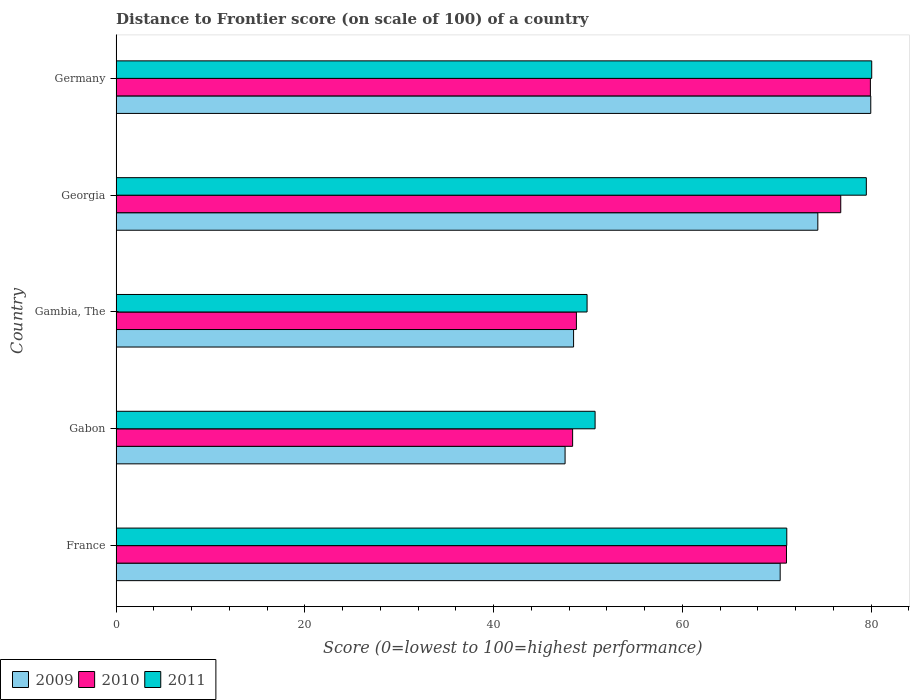How many different coloured bars are there?
Make the answer very short. 3. What is the label of the 1st group of bars from the top?
Give a very brief answer. Germany. In how many cases, is the number of bars for a given country not equal to the number of legend labels?
Provide a succinct answer. 0. What is the distance to frontier score of in 2010 in Gambia, The?
Ensure brevity in your answer.  48.77. Across all countries, what is the maximum distance to frontier score of in 2010?
Provide a succinct answer. 79.92. Across all countries, what is the minimum distance to frontier score of in 2011?
Offer a terse response. 49.9. In which country was the distance to frontier score of in 2010 maximum?
Make the answer very short. Germany. In which country was the distance to frontier score of in 2011 minimum?
Provide a succinct answer. Gambia, The. What is the total distance to frontier score of in 2010 in the graph?
Make the answer very short. 324.87. What is the difference between the distance to frontier score of in 2011 in France and that in Georgia?
Keep it short and to the point. -8.43. What is the difference between the distance to frontier score of in 2009 in Gambia, The and the distance to frontier score of in 2011 in France?
Make the answer very short. -22.59. What is the average distance to frontier score of in 2009 per country?
Provide a short and direct response. 64.14. What is the difference between the distance to frontier score of in 2011 and distance to frontier score of in 2009 in Gabon?
Your answer should be very brief. 3.18. In how many countries, is the distance to frontier score of in 2010 greater than 20 ?
Provide a short and direct response. 5. What is the ratio of the distance to frontier score of in 2011 in France to that in Georgia?
Offer a very short reply. 0.89. Is the distance to frontier score of in 2011 in France less than that in Gabon?
Offer a terse response. No. Is the difference between the distance to frontier score of in 2011 in France and Gambia, The greater than the difference between the distance to frontier score of in 2009 in France and Gambia, The?
Provide a succinct answer. No. What is the difference between the highest and the second highest distance to frontier score of in 2010?
Your answer should be compact. 3.14. What is the difference between the highest and the lowest distance to frontier score of in 2009?
Your answer should be very brief. 32.39. What does the 2nd bar from the top in Gambia, The represents?
Offer a very short reply. 2010. How many bars are there?
Your answer should be very brief. 15. Are all the bars in the graph horizontal?
Make the answer very short. Yes. How many countries are there in the graph?
Your response must be concise. 5. What is the difference between two consecutive major ticks on the X-axis?
Make the answer very short. 20. Are the values on the major ticks of X-axis written in scientific E-notation?
Keep it short and to the point. No. Does the graph contain grids?
Your response must be concise. No. Where does the legend appear in the graph?
Your answer should be very brief. Bottom left. How many legend labels are there?
Give a very brief answer. 3. How are the legend labels stacked?
Your response must be concise. Horizontal. What is the title of the graph?
Your answer should be very brief. Distance to Frontier score (on scale of 100) of a country. Does "2006" appear as one of the legend labels in the graph?
Make the answer very short. No. What is the label or title of the X-axis?
Your response must be concise. Score (0=lowest to 100=highest performance). What is the Score (0=lowest to 100=highest performance) in 2009 in France?
Provide a succinct answer. 70.36. What is the Score (0=lowest to 100=highest performance) of 2010 in France?
Offer a very short reply. 71.03. What is the Score (0=lowest to 100=highest performance) in 2011 in France?
Keep it short and to the point. 71.06. What is the Score (0=lowest to 100=highest performance) in 2009 in Gabon?
Ensure brevity in your answer.  47.57. What is the Score (0=lowest to 100=highest performance) of 2010 in Gabon?
Make the answer very short. 48.37. What is the Score (0=lowest to 100=highest performance) of 2011 in Gabon?
Offer a very short reply. 50.75. What is the Score (0=lowest to 100=highest performance) of 2009 in Gambia, The?
Make the answer very short. 48.47. What is the Score (0=lowest to 100=highest performance) in 2010 in Gambia, The?
Your answer should be compact. 48.77. What is the Score (0=lowest to 100=highest performance) of 2011 in Gambia, The?
Ensure brevity in your answer.  49.9. What is the Score (0=lowest to 100=highest performance) of 2009 in Georgia?
Your answer should be very brief. 74.35. What is the Score (0=lowest to 100=highest performance) of 2010 in Georgia?
Your answer should be very brief. 76.78. What is the Score (0=lowest to 100=highest performance) in 2011 in Georgia?
Your answer should be compact. 79.49. What is the Score (0=lowest to 100=highest performance) of 2009 in Germany?
Give a very brief answer. 79.96. What is the Score (0=lowest to 100=highest performance) in 2010 in Germany?
Provide a short and direct response. 79.92. What is the Score (0=lowest to 100=highest performance) of 2011 in Germany?
Your answer should be very brief. 80.06. Across all countries, what is the maximum Score (0=lowest to 100=highest performance) in 2009?
Your answer should be compact. 79.96. Across all countries, what is the maximum Score (0=lowest to 100=highest performance) of 2010?
Ensure brevity in your answer.  79.92. Across all countries, what is the maximum Score (0=lowest to 100=highest performance) of 2011?
Provide a short and direct response. 80.06. Across all countries, what is the minimum Score (0=lowest to 100=highest performance) of 2009?
Make the answer very short. 47.57. Across all countries, what is the minimum Score (0=lowest to 100=highest performance) of 2010?
Ensure brevity in your answer.  48.37. Across all countries, what is the minimum Score (0=lowest to 100=highest performance) of 2011?
Provide a succinct answer. 49.9. What is the total Score (0=lowest to 100=highest performance) of 2009 in the graph?
Your answer should be very brief. 320.71. What is the total Score (0=lowest to 100=highest performance) of 2010 in the graph?
Provide a succinct answer. 324.87. What is the total Score (0=lowest to 100=highest performance) in 2011 in the graph?
Make the answer very short. 331.26. What is the difference between the Score (0=lowest to 100=highest performance) of 2009 in France and that in Gabon?
Offer a very short reply. 22.79. What is the difference between the Score (0=lowest to 100=highest performance) of 2010 in France and that in Gabon?
Your answer should be very brief. 22.66. What is the difference between the Score (0=lowest to 100=highest performance) of 2011 in France and that in Gabon?
Offer a terse response. 20.31. What is the difference between the Score (0=lowest to 100=highest performance) of 2009 in France and that in Gambia, The?
Provide a short and direct response. 21.89. What is the difference between the Score (0=lowest to 100=highest performance) in 2010 in France and that in Gambia, The?
Ensure brevity in your answer.  22.26. What is the difference between the Score (0=lowest to 100=highest performance) of 2011 in France and that in Gambia, The?
Provide a short and direct response. 21.16. What is the difference between the Score (0=lowest to 100=highest performance) in 2009 in France and that in Georgia?
Provide a succinct answer. -3.99. What is the difference between the Score (0=lowest to 100=highest performance) in 2010 in France and that in Georgia?
Ensure brevity in your answer.  -5.75. What is the difference between the Score (0=lowest to 100=highest performance) of 2011 in France and that in Georgia?
Offer a very short reply. -8.43. What is the difference between the Score (0=lowest to 100=highest performance) of 2010 in France and that in Germany?
Give a very brief answer. -8.89. What is the difference between the Score (0=lowest to 100=highest performance) of 2011 in France and that in Germany?
Your answer should be compact. -9. What is the difference between the Score (0=lowest to 100=highest performance) of 2009 in Gabon and that in Georgia?
Provide a short and direct response. -26.78. What is the difference between the Score (0=lowest to 100=highest performance) of 2010 in Gabon and that in Georgia?
Your response must be concise. -28.41. What is the difference between the Score (0=lowest to 100=highest performance) of 2011 in Gabon and that in Georgia?
Ensure brevity in your answer.  -28.74. What is the difference between the Score (0=lowest to 100=highest performance) in 2009 in Gabon and that in Germany?
Provide a succinct answer. -32.39. What is the difference between the Score (0=lowest to 100=highest performance) in 2010 in Gabon and that in Germany?
Provide a short and direct response. -31.55. What is the difference between the Score (0=lowest to 100=highest performance) of 2011 in Gabon and that in Germany?
Ensure brevity in your answer.  -29.31. What is the difference between the Score (0=lowest to 100=highest performance) of 2009 in Gambia, The and that in Georgia?
Your response must be concise. -25.88. What is the difference between the Score (0=lowest to 100=highest performance) in 2010 in Gambia, The and that in Georgia?
Provide a succinct answer. -28.01. What is the difference between the Score (0=lowest to 100=highest performance) in 2011 in Gambia, The and that in Georgia?
Ensure brevity in your answer.  -29.59. What is the difference between the Score (0=lowest to 100=highest performance) in 2009 in Gambia, The and that in Germany?
Make the answer very short. -31.49. What is the difference between the Score (0=lowest to 100=highest performance) in 2010 in Gambia, The and that in Germany?
Your response must be concise. -31.15. What is the difference between the Score (0=lowest to 100=highest performance) of 2011 in Gambia, The and that in Germany?
Your answer should be compact. -30.16. What is the difference between the Score (0=lowest to 100=highest performance) of 2009 in Georgia and that in Germany?
Your answer should be very brief. -5.61. What is the difference between the Score (0=lowest to 100=highest performance) in 2010 in Georgia and that in Germany?
Give a very brief answer. -3.14. What is the difference between the Score (0=lowest to 100=highest performance) of 2011 in Georgia and that in Germany?
Provide a short and direct response. -0.57. What is the difference between the Score (0=lowest to 100=highest performance) in 2009 in France and the Score (0=lowest to 100=highest performance) in 2010 in Gabon?
Give a very brief answer. 21.99. What is the difference between the Score (0=lowest to 100=highest performance) in 2009 in France and the Score (0=lowest to 100=highest performance) in 2011 in Gabon?
Keep it short and to the point. 19.61. What is the difference between the Score (0=lowest to 100=highest performance) of 2010 in France and the Score (0=lowest to 100=highest performance) of 2011 in Gabon?
Ensure brevity in your answer.  20.28. What is the difference between the Score (0=lowest to 100=highest performance) in 2009 in France and the Score (0=lowest to 100=highest performance) in 2010 in Gambia, The?
Offer a very short reply. 21.59. What is the difference between the Score (0=lowest to 100=highest performance) in 2009 in France and the Score (0=lowest to 100=highest performance) in 2011 in Gambia, The?
Give a very brief answer. 20.46. What is the difference between the Score (0=lowest to 100=highest performance) of 2010 in France and the Score (0=lowest to 100=highest performance) of 2011 in Gambia, The?
Your response must be concise. 21.13. What is the difference between the Score (0=lowest to 100=highest performance) of 2009 in France and the Score (0=lowest to 100=highest performance) of 2010 in Georgia?
Provide a succinct answer. -6.42. What is the difference between the Score (0=lowest to 100=highest performance) in 2009 in France and the Score (0=lowest to 100=highest performance) in 2011 in Georgia?
Provide a succinct answer. -9.13. What is the difference between the Score (0=lowest to 100=highest performance) of 2010 in France and the Score (0=lowest to 100=highest performance) of 2011 in Georgia?
Ensure brevity in your answer.  -8.46. What is the difference between the Score (0=lowest to 100=highest performance) of 2009 in France and the Score (0=lowest to 100=highest performance) of 2010 in Germany?
Offer a terse response. -9.56. What is the difference between the Score (0=lowest to 100=highest performance) in 2010 in France and the Score (0=lowest to 100=highest performance) in 2011 in Germany?
Offer a very short reply. -9.03. What is the difference between the Score (0=lowest to 100=highest performance) of 2009 in Gabon and the Score (0=lowest to 100=highest performance) of 2011 in Gambia, The?
Your answer should be compact. -2.33. What is the difference between the Score (0=lowest to 100=highest performance) of 2010 in Gabon and the Score (0=lowest to 100=highest performance) of 2011 in Gambia, The?
Keep it short and to the point. -1.53. What is the difference between the Score (0=lowest to 100=highest performance) of 2009 in Gabon and the Score (0=lowest to 100=highest performance) of 2010 in Georgia?
Your answer should be very brief. -29.21. What is the difference between the Score (0=lowest to 100=highest performance) in 2009 in Gabon and the Score (0=lowest to 100=highest performance) in 2011 in Georgia?
Provide a short and direct response. -31.92. What is the difference between the Score (0=lowest to 100=highest performance) in 2010 in Gabon and the Score (0=lowest to 100=highest performance) in 2011 in Georgia?
Your answer should be compact. -31.12. What is the difference between the Score (0=lowest to 100=highest performance) of 2009 in Gabon and the Score (0=lowest to 100=highest performance) of 2010 in Germany?
Ensure brevity in your answer.  -32.35. What is the difference between the Score (0=lowest to 100=highest performance) in 2009 in Gabon and the Score (0=lowest to 100=highest performance) in 2011 in Germany?
Offer a terse response. -32.49. What is the difference between the Score (0=lowest to 100=highest performance) of 2010 in Gabon and the Score (0=lowest to 100=highest performance) of 2011 in Germany?
Your answer should be compact. -31.69. What is the difference between the Score (0=lowest to 100=highest performance) in 2009 in Gambia, The and the Score (0=lowest to 100=highest performance) in 2010 in Georgia?
Your response must be concise. -28.31. What is the difference between the Score (0=lowest to 100=highest performance) in 2009 in Gambia, The and the Score (0=lowest to 100=highest performance) in 2011 in Georgia?
Offer a very short reply. -31.02. What is the difference between the Score (0=lowest to 100=highest performance) in 2010 in Gambia, The and the Score (0=lowest to 100=highest performance) in 2011 in Georgia?
Make the answer very short. -30.72. What is the difference between the Score (0=lowest to 100=highest performance) in 2009 in Gambia, The and the Score (0=lowest to 100=highest performance) in 2010 in Germany?
Offer a terse response. -31.45. What is the difference between the Score (0=lowest to 100=highest performance) of 2009 in Gambia, The and the Score (0=lowest to 100=highest performance) of 2011 in Germany?
Ensure brevity in your answer.  -31.59. What is the difference between the Score (0=lowest to 100=highest performance) in 2010 in Gambia, The and the Score (0=lowest to 100=highest performance) in 2011 in Germany?
Offer a terse response. -31.29. What is the difference between the Score (0=lowest to 100=highest performance) in 2009 in Georgia and the Score (0=lowest to 100=highest performance) in 2010 in Germany?
Your answer should be compact. -5.57. What is the difference between the Score (0=lowest to 100=highest performance) in 2009 in Georgia and the Score (0=lowest to 100=highest performance) in 2011 in Germany?
Ensure brevity in your answer.  -5.71. What is the difference between the Score (0=lowest to 100=highest performance) in 2010 in Georgia and the Score (0=lowest to 100=highest performance) in 2011 in Germany?
Your response must be concise. -3.28. What is the average Score (0=lowest to 100=highest performance) in 2009 per country?
Provide a short and direct response. 64.14. What is the average Score (0=lowest to 100=highest performance) of 2010 per country?
Keep it short and to the point. 64.97. What is the average Score (0=lowest to 100=highest performance) in 2011 per country?
Your answer should be very brief. 66.25. What is the difference between the Score (0=lowest to 100=highest performance) of 2009 and Score (0=lowest to 100=highest performance) of 2010 in France?
Provide a short and direct response. -0.67. What is the difference between the Score (0=lowest to 100=highest performance) of 2009 and Score (0=lowest to 100=highest performance) of 2011 in France?
Make the answer very short. -0.7. What is the difference between the Score (0=lowest to 100=highest performance) of 2010 and Score (0=lowest to 100=highest performance) of 2011 in France?
Provide a short and direct response. -0.03. What is the difference between the Score (0=lowest to 100=highest performance) of 2009 and Score (0=lowest to 100=highest performance) of 2011 in Gabon?
Provide a succinct answer. -3.18. What is the difference between the Score (0=lowest to 100=highest performance) in 2010 and Score (0=lowest to 100=highest performance) in 2011 in Gabon?
Offer a terse response. -2.38. What is the difference between the Score (0=lowest to 100=highest performance) in 2009 and Score (0=lowest to 100=highest performance) in 2011 in Gambia, The?
Make the answer very short. -1.43. What is the difference between the Score (0=lowest to 100=highest performance) of 2010 and Score (0=lowest to 100=highest performance) of 2011 in Gambia, The?
Give a very brief answer. -1.13. What is the difference between the Score (0=lowest to 100=highest performance) of 2009 and Score (0=lowest to 100=highest performance) of 2010 in Georgia?
Give a very brief answer. -2.43. What is the difference between the Score (0=lowest to 100=highest performance) in 2009 and Score (0=lowest to 100=highest performance) in 2011 in Georgia?
Offer a very short reply. -5.14. What is the difference between the Score (0=lowest to 100=highest performance) in 2010 and Score (0=lowest to 100=highest performance) in 2011 in Georgia?
Offer a terse response. -2.71. What is the difference between the Score (0=lowest to 100=highest performance) of 2009 and Score (0=lowest to 100=highest performance) of 2010 in Germany?
Offer a very short reply. 0.04. What is the difference between the Score (0=lowest to 100=highest performance) in 2009 and Score (0=lowest to 100=highest performance) in 2011 in Germany?
Provide a succinct answer. -0.1. What is the difference between the Score (0=lowest to 100=highest performance) in 2010 and Score (0=lowest to 100=highest performance) in 2011 in Germany?
Your response must be concise. -0.14. What is the ratio of the Score (0=lowest to 100=highest performance) in 2009 in France to that in Gabon?
Offer a terse response. 1.48. What is the ratio of the Score (0=lowest to 100=highest performance) of 2010 in France to that in Gabon?
Keep it short and to the point. 1.47. What is the ratio of the Score (0=lowest to 100=highest performance) in 2011 in France to that in Gabon?
Offer a terse response. 1.4. What is the ratio of the Score (0=lowest to 100=highest performance) of 2009 in France to that in Gambia, The?
Offer a very short reply. 1.45. What is the ratio of the Score (0=lowest to 100=highest performance) of 2010 in France to that in Gambia, The?
Give a very brief answer. 1.46. What is the ratio of the Score (0=lowest to 100=highest performance) of 2011 in France to that in Gambia, The?
Your answer should be compact. 1.42. What is the ratio of the Score (0=lowest to 100=highest performance) of 2009 in France to that in Georgia?
Ensure brevity in your answer.  0.95. What is the ratio of the Score (0=lowest to 100=highest performance) of 2010 in France to that in Georgia?
Provide a succinct answer. 0.93. What is the ratio of the Score (0=lowest to 100=highest performance) in 2011 in France to that in Georgia?
Keep it short and to the point. 0.89. What is the ratio of the Score (0=lowest to 100=highest performance) of 2009 in France to that in Germany?
Ensure brevity in your answer.  0.88. What is the ratio of the Score (0=lowest to 100=highest performance) in 2010 in France to that in Germany?
Keep it short and to the point. 0.89. What is the ratio of the Score (0=lowest to 100=highest performance) in 2011 in France to that in Germany?
Provide a short and direct response. 0.89. What is the ratio of the Score (0=lowest to 100=highest performance) of 2009 in Gabon to that in Gambia, The?
Make the answer very short. 0.98. What is the ratio of the Score (0=lowest to 100=highest performance) of 2009 in Gabon to that in Georgia?
Your answer should be compact. 0.64. What is the ratio of the Score (0=lowest to 100=highest performance) in 2010 in Gabon to that in Georgia?
Your response must be concise. 0.63. What is the ratio of the Score (0=lowest to 100=highest performance) in 2011 in Gabon to that in Georgia?
Provide a succinct answer. 0.64. What is the ratio of the Score (0=lowest to 100=highest performance) in 2009 in Gabon to that in Germany?
Keep it short and to the point. 0.59. What is the ratio of the Score (0=lowest to 100=highest performance) of 2010 in Gabon to that in Germany?
Keep it short and to the point. 0.61. What is the ratio of the Score (0=lowest to 100=highest performance) of 2011 in Gabon to that in Germany?
Your answer should be compact. 0.63. What is the ratio of the Score (0=lowest to 100=highest performance) of 2009 in Gambia, The to that in Georgia?
Keep it short and to the point. 0.65. What is the ratio of the Score (0=lowest to 100=highest performance) in 2010 in Gambia, The to that in Georgia?
Ensure brevity in your answer.  0.64. What is the ratio of the Score (0=lowest to 100=highest performance) in 2011 in Gambia, The to that in Georgia?
Ensure brevity in your answer.  0.63. What is the ratio of the Score (0=lowest to 100=highest performance) in 2009 in Gambia, The to that in Germany?
Ensure brevity in your answer.  0.61. What is the ratio of the Score (0=lowest to 100=highest performance) in 2010 in Gambia, The to that in Germany?
Give a very brief answer. 0.61. What is the ratio of the Score (0=lowest to 100=highest performance) of 2011 in Gambia, The to that in Germany?
Your answer should be very brief. 0.62. What is the ratio of the Score (0=lowest to 100=highest performance) of 2009 in Georgia to that in Germany?
Keep it short and to the point. 0.93. What is the ratio of the Score (0=lowest to 100=highest performance) in 2010 in Georgia to that in Germany?
Your response must be concise. 0.96. What is the ratio of the Score (0=lowest to 100=highest performance) in 2011 in Georgia to that in Germany?
Your response must be concise. 0.99. What is the difference between the highest and the second highest Score (0=lowest to 100=highest performance) in 2009?
Provide a succinct answer. 5.61. What is the difference between the highest and the second highest Score (0=lowest to 100=highest performance) in 2010?
Provide a short and direct response. 3.14. What is the difference between the highest and the second highest Score (0=lowest to 100=highest performance) of 2011?
Your answer should be compact. 0.57. What is the difference between the highest and the lowest Score (0=lowest to 100=highest performance) in 2009?
Provide a short and direct response. 32.39. What is the difference between the highest and the lowest Score (0=lowest to 100=highest performance) in 2010?
Make the answer very short. 31.55. What is the difference between the highest and the lowest Score (0=lowest to 100=highest performance) in 2011?
Your answer should be compact. 30.16. 